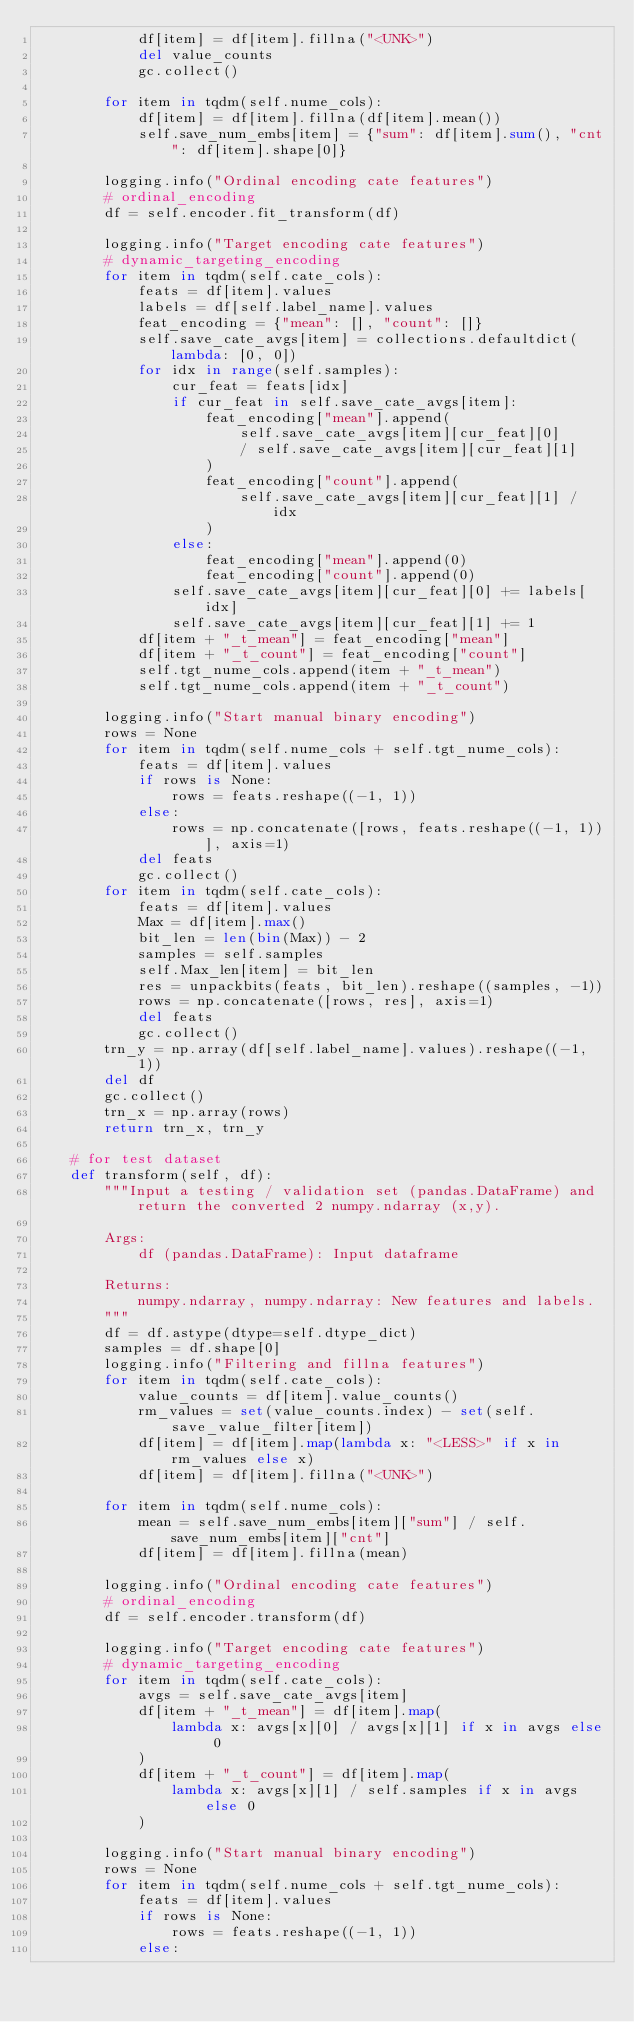Convert code to text. <code><loc_0><loc_0><loc_500><loc_500><_Python_>            df[item] = df[item].fillna("<UNK>")
            del value_counts
            gc.collect()

        for item in tqdm(self.nume_cols):
            df[item] = df[item].fillna(df[item].mean())
            self.save_num_embs[item] = {"sum": df[item].sum(), "cnt": df[item].shape[0]}

        logging.info("Ordinal encoding cate features")
        # ordinal_encoding
        df = self.encoder.fit_transform(df)

        logging.info("Target encoding cate features")
        # dynamic_targeting_encoding
        for item in tqdm(self.cate_cols):
            feats = df[item].values
            labels = df[self.label_name].values
            feat_encoding = {"mean": [], "count": []}
            self.save_cate_avgs[item] = collections.defaultdict(lambda: [0, 0])
            for idx in range(self.samples):
                cur_feat = feats[idx]
                if cur_feat in self.save_cate_avgs[item]:
                    feat_encoding["mean"].append(
                        self.save_cate_avgs[item][cur_feat][0]
                        / self.save_cate_avgs[item][cur_feat][1]
                    )
                    feat_encoding["count"].append(
                        self.save_cate_avgs[item][cur_feat][1] / idx
                    )
                else:
                    feat_encoding["mean"].append(0)
                    feat_encoding["count"].append(0)
                self.save_cate_avgs[item][cur_feat][0] += labels[idx]
                self.save_cate_avgs[item][cur_feat][1] += 1
            df[item + "_t_mean"] = feat_encoding["mean"]
            df[item + "_t_count"] = feat_encoding["count"]
            self.tgt_nume_cols.append(item + "_t_mean")
            self.tgt_nume_cols.append(item + "_t_count")

        logging.info("Start manual binary encoding")
        rows = None
        for item in tqdm(self.nume_cols + self.tgt_nume_cols):
            feats = df[item].values
            if rows is None:
                rows = feats.reshape((-1, 1))
            else:
                rows = np.concatenate([rows, feats.reshape((-1, 1))], axis=1)
            del feats
            gc.collect()
        for item in tqdm(self.cate_cols):
            feats = df[item].values
            Max = df[item].max()
            bit_len = len(bin(Max)) - 2
            samples = self.samples
            self.Max_len[item] = bit_len
            res = unpackbits(feats, bit_len).reshape((samples, -1))
            rows = np.concatenate([rows, res], axis=1)
            del feats
            gc.collect()
        trn_y = np.array(df[self.label_name].values).reshape((-1, 1))
        del df
        gc.collect()
        trn_x = np.array(rows)
        return trn_x, trn_y

    # for test dataset
    def transform(self, df):
        """Input a testing / validation set (pandas.DataFrame) and return the converted 2 numpy.ndarray (x,y).

        Args:
            df (pandas.DataFrame): Input dataframe

        Returns:
            numpy.ndarray, numpy.ndarray: New features and labels.
        """
        df = df.astype(dtype=self.dtype_dict)
        samples = df.shape[0]
        logging.info("Filtering and fillna features")
        for item in tqdm(self.cate_cols):
            value_counts = df[item].value_counts()
            rm_values = set(value_counts.index) - set(self.save_value_filter[item])
            df[item] = df[item].map(lambda x: "<LESS>" if x in rm_values else x)
            df[item] = df[item].fillna("<UNK>")

        for item in tqdm(self.nume_cols):
            mean = self.save_num_embs[item]["sum"] / self.save_num_embs[item]["cnt"]
            df[item] = df[item].fillna(mean)

        logging.info("Ordinal encoding cate features")
        # ordinal_encoding
        df = self.encoder.transform(df)

        logging.info("Target encoding cate features")
        # dynamic_targeting_encoding
        for item in tqdm(self.cate_cols):
            avgs = self.save_cate_avgs[item]
            df[item + "_t_mean"] = df[item].map(
                lambda x: avgs[x][0] / avgs[x][1] if x in avgs else 0
            )
            df[item + "_t_count"] = df[item].map(
                lambda x: avgs[x][1] / self.samples if x in avgs else 0
            )

        logging.info("Start manual binary encoding")
        rows = None
        for item in tqdm(self.nume_cols + self.tgt_nume_cols):
            feats = df[item].values
            if rows is None:
                rows = feats.reshape((-1, 1))
            else:</code> 